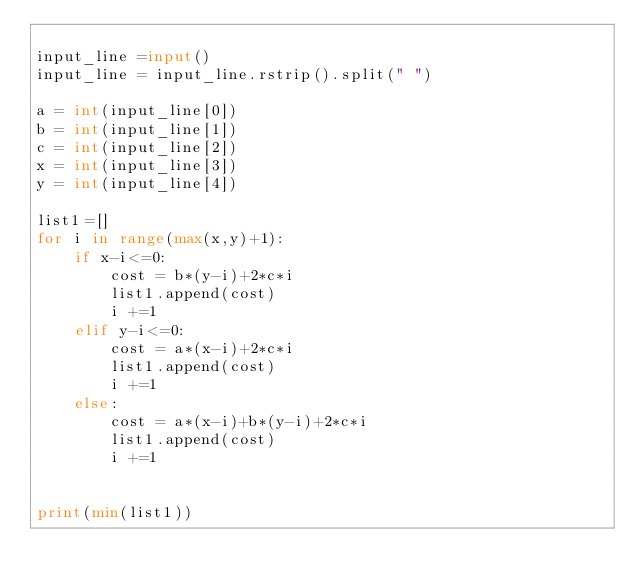<code> <loc_0><loc_0><loc_500><loc_500><_Python_>
input_line =input()
input_line = input_line.rstrip().split(" ")

a = int(input_line[0])
b = int(input_line[1])
c = int(input_line[2])
x = int(input_line[3])
y = int(input_line[4])

list1=[]
for i in range(max(x,y)+1):
    if x-i<=0:
        cost = b*(y-i)+2*c*i
        list1.append(cost)
        i +=1
    elif y-i<=0:
        cost = a*(x-i)+2*c*i
        list1.append(cost)
        i +=1
    else:
        cost = a*(x-i)+b*(y-i)+2*c*i
        list1.append(cost)
        i +=1
    

print(min(list1))
</code> 